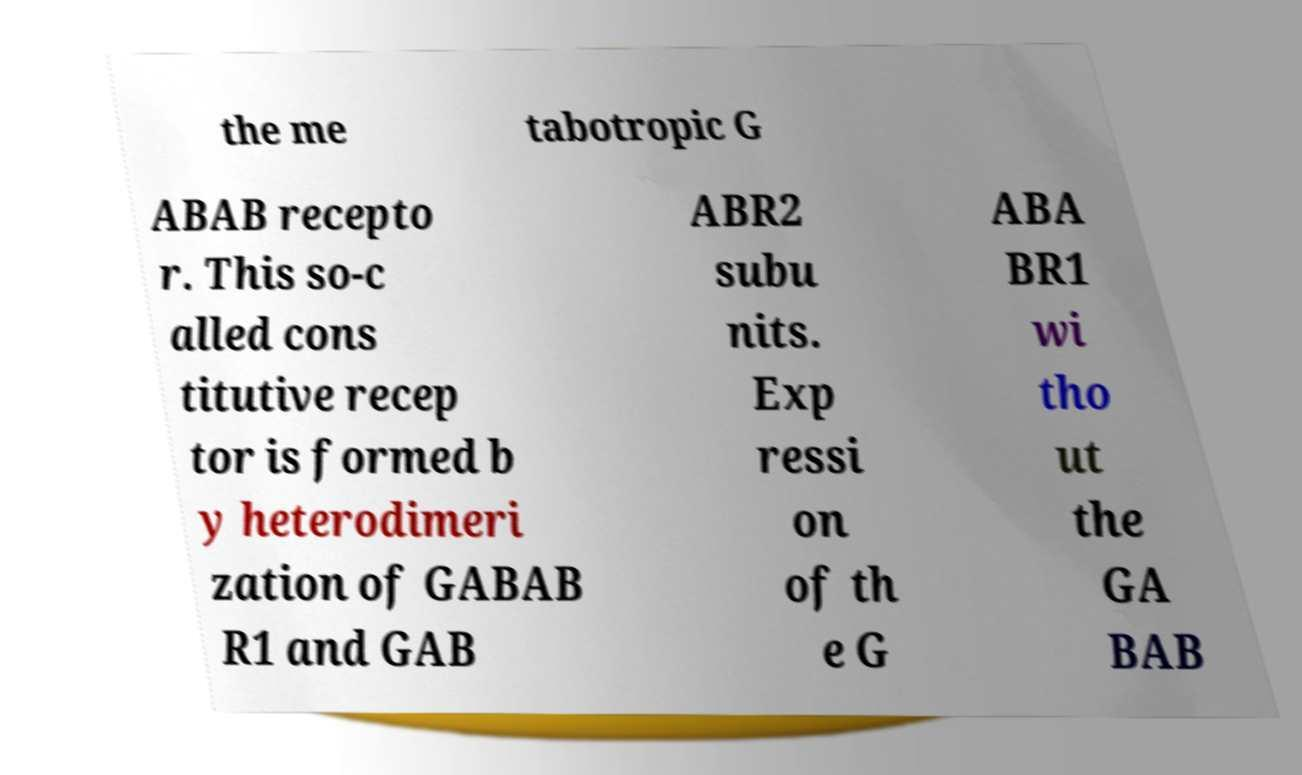Please identify and transcribe the text found in this image. the me tabotropic G ABAB recepto r. This so-c alled cons titutive recep tor is formed b y heterodimeri zation of GABAB R1 and GAB ABR2 subu nits. Exp ressi on of th e G ABA BR1 wi tho ut the GA BAB 